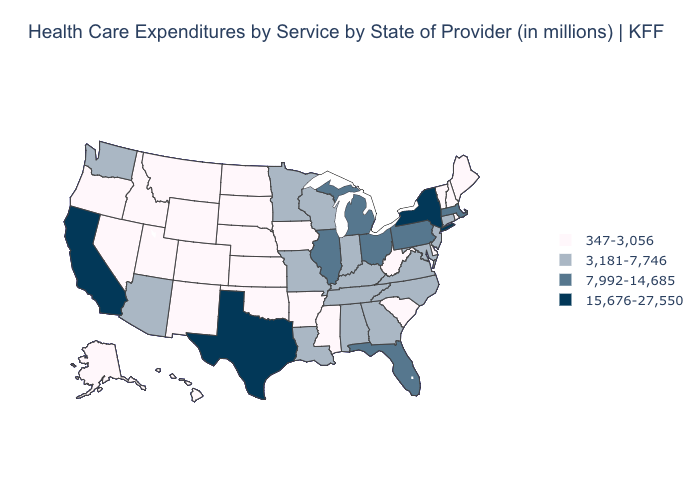Name the states that have a value in the range 15,676-27,550?
Write a very short answer. California, New York, Texas. What is the value of Missouri?
Write a very short answer. 3,181-7,746. Name the states that have a value in the range 7,992-14,685?
Short answer required. Florida, Illinois, Massachusetts, Michigan, Ohio, Pennsylvania. Which states hav the highest value in the MidWest?
Be succinct. Illinois, Michigan, Ohio. What is the value of Kentucky?
Quick response, please. 3,181-7,746. What is the value of Louisiana?
Keep it brief. 3,181-7,746. Name the states that have a value in the range 347-3,056?
Be succinct. Alaska, Arkansas, Colorado, Delaware, Hawaii, Idaho, Iowa, Kansas, Maine, Mississippi, Montana, Nebraska, Nevada, New Hampshire, New Mexico, North Dakota, Oklahoma, Oregon, Rhode Island, South Carolina, South Dakota, Utah, Vermont, West Virginia, Wyoming. Which states have the highest value in the USA?
Be succinct. California, New York, Texas. Does California have the highest value in the West?
Write a very short answer. Yes. What is the lowest value in the South?
Concise answer only. 347-3,056. Among the states that border South Dakota , does Minnesota have the highest value?
Write a very short answer. Yes. Does Idaho have the lowest value in the USA?
Write a very short answer. Yes. What is the value of Montana?
Short answer required. 347-3,056. Which states have the lowest value in the USA?
Answer briefly. Alaska, Arkansas, Colorado, Delaware, Hawaii, Idaho, Iowa, Kansas, Maine, Mississippi, Montana, Nebraska, Nevada, New Hampshire, New Mexico, North Dakota, Oklahoma, Oregon, Rhode Island, South Carolina, South Dakota, Utah, Vermont, West Virginia, Wyoming. Name the states that have a value in the range 7,992-14,685?
Quick response, please. Florida, Illinois, Massachusetts, Michigan, Ohio, Pennsylvania. 